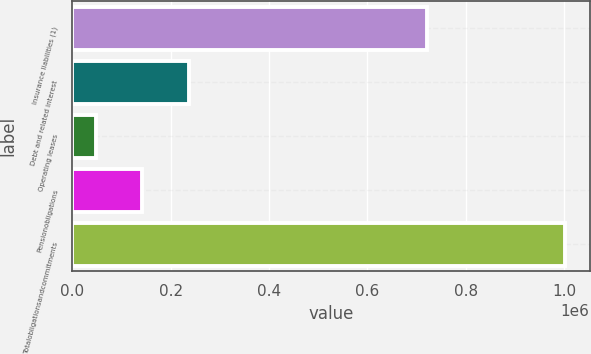Convert chart to OTSL. <chart><loc_0><loc_0><loc_500><loc_500><bar_chart><fcel>Insurance liabilities (1)<fcel>Debt and related interest<fcel>Operating leases<fcel>Pensionobligations<fcel>Totalobligationsandcommitments<nl><fcel>721434<fcel>238248<fcel>47278<fcel>142763<fcel>1.00213e+06<nl></chart> 